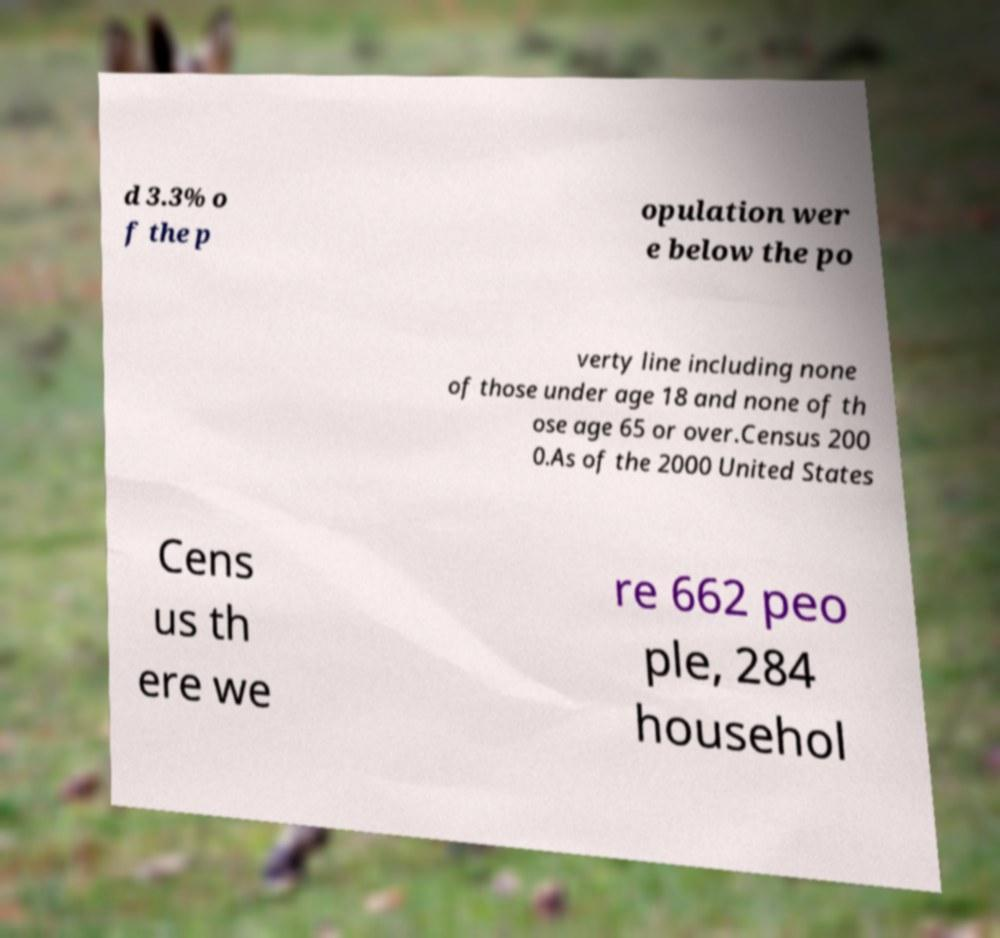Could you assist in decoding the text presented in this image and type it out clearly? d 3.3% o f the p opulation wer e below the po verty line including none of those under age 18 and none of th ose age 65 or over.Census 200 0.As of the 2000 United States Cens us th ere we re 662 peo ple, 284 househol 